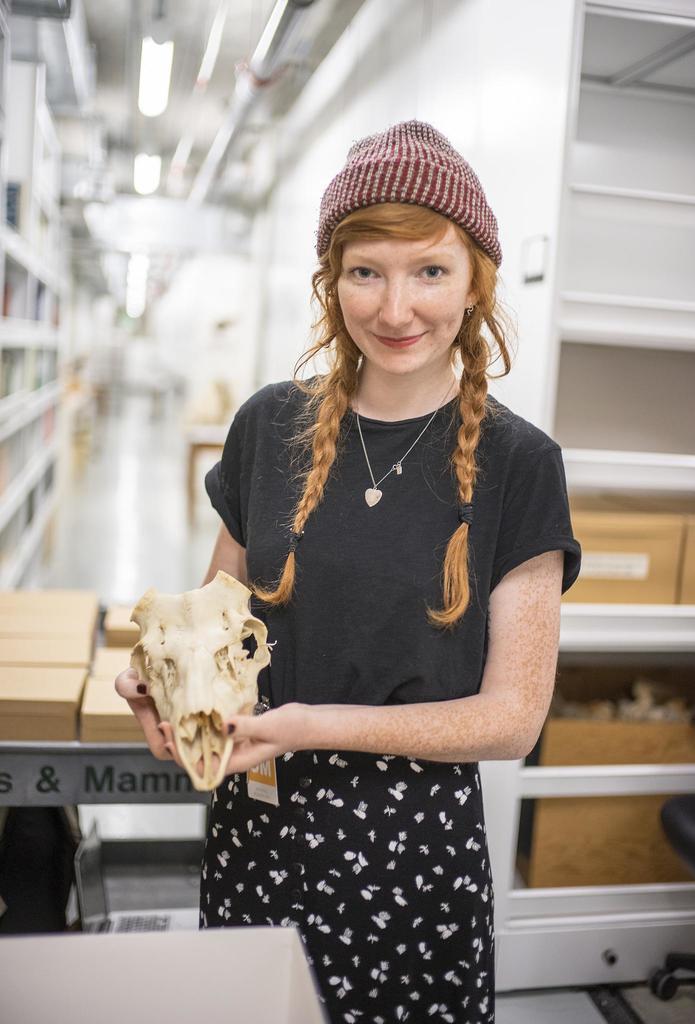Could you give a brief overview of what you see in this image? In this image there is a girl standing and holding skull of an animal behind her there is a table and so many racks. 